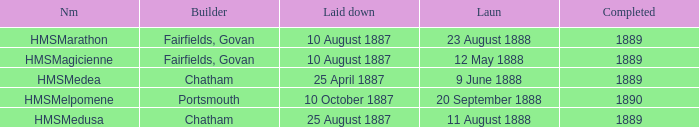Which builder completed before 1890 and launched on 9 june 1888? Chatham. 